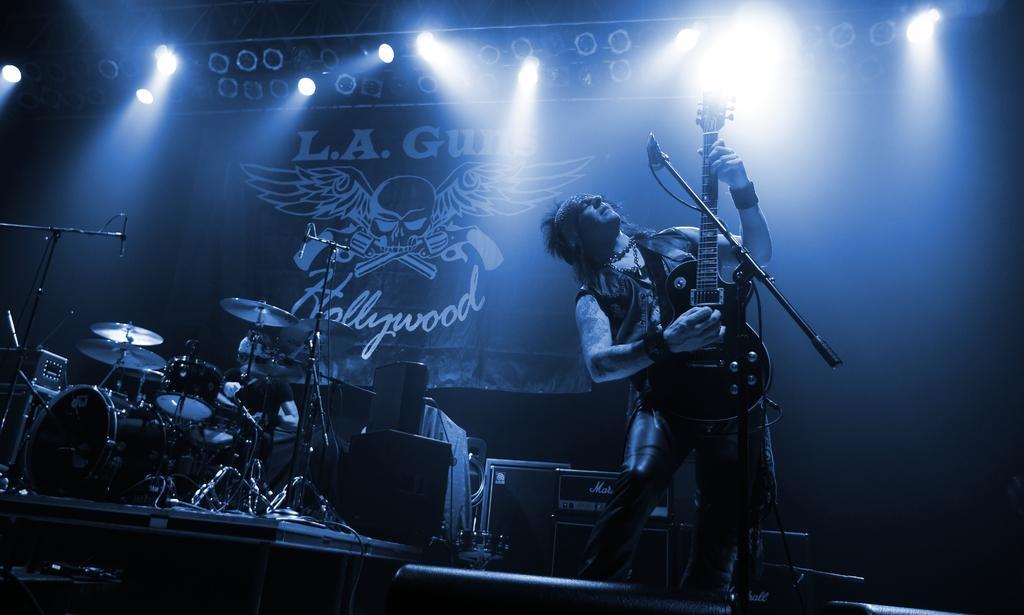In one or two sentences, can you explain what this image depicts? We can see there is a man who is holding guitar in his hand and beside him there is a drum set and speakers on the stage. 